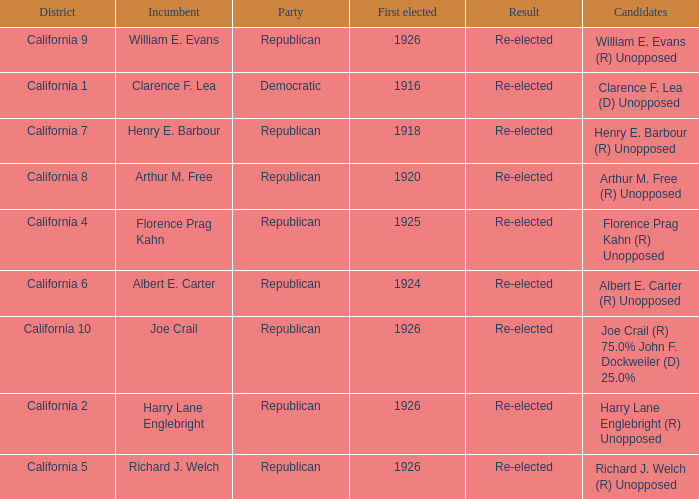What's the districtwith party being democratic California 1. Could you parse the entire table? {'header': ['District', 'Incumbent', 'Party', 'First elected', 'Result', 'Candidates'], 'rows': [['California 9', 'William E. Evans', 'Republican', '1926', 'Re-elected', 'William E. Evans (R) Unopposed'], ['California 1', 'Clarence F. Lea', 'Democratic', '1916', 'Re-elected', 'Clarence F. Lea (D) Unopposed'], ['California 7', 'Henry E. Barbour', 'Republican', '1918', 'Re-elected', 'Henry E. Barbour (R) Unopposed'], ['California 8', 'Arthur M. Free', 'Republican', '1920', 'Re-elected', 'Arthur M. Free (R) Unopposed'], ['California 4', 'Florence Prag Kahn', 'Republican', '1925', 'Re-elected', 'Florence Prag Kahn (R) Unopposed'], ['California 6', 'Albert E. Carter', 'Republican', '1924', 'Re-elected', 'Albert E. Carter (R) Unopposed'], ['California 10', 'Joe Crail', 'Republican', '1926', 'Re-elected', 'Joe Crail (R) 75.0% John F. Dockweiler (D) 25.0%'], ['California 2', 'Harry Lane Englebright', 'Republican', '1926', 'Re-elected', 'Harry Lane Englebright (R) Unopposed'], ['California 5', 'Richard J. Welch', 'Republican', '1926', 'Re-elected', 'Richard J. Welch (R) Unopposed']]} 